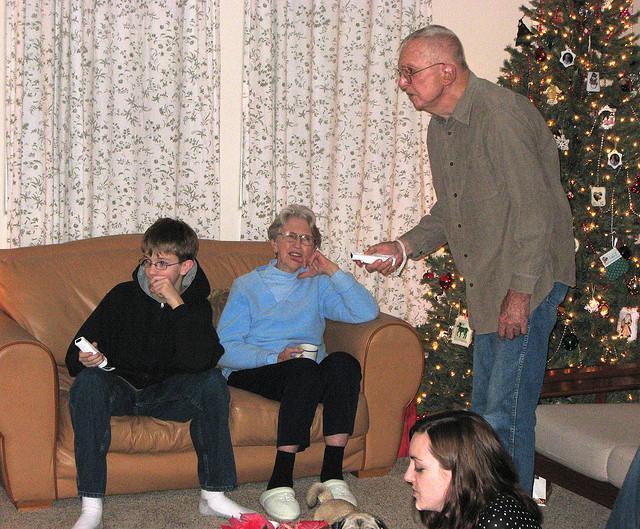How many couches are in the picture?
Give a very brief answer. 2. How many people are in the picture?
Give a very brief answer. 4. 